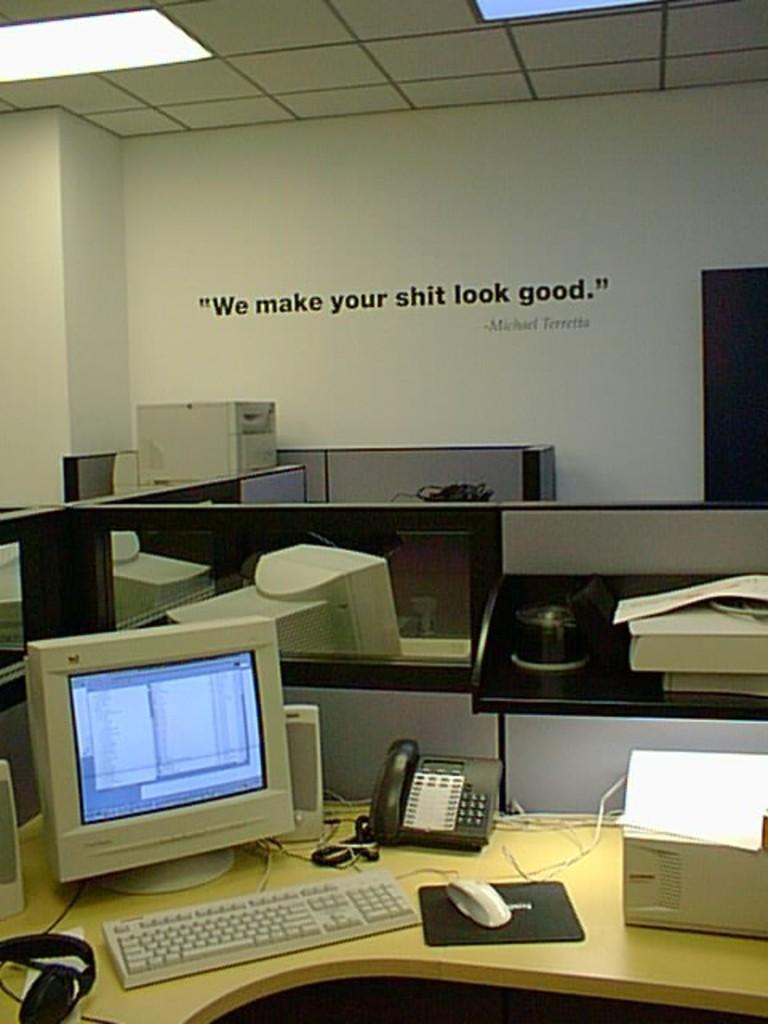What type of environment is depicted in the image? The image appears to depict an office setting. What can be seen on the desk in the image? Monitors, keyboards, mice, and phones are present on the desk. Are there any dividers in the room? Yes, there are partitions in the room. What phrase is written on the wall in the image? The phrase "We make your shit look good" is written on a wall. Can you see a wrench being used in the image? No, there is no wrench present in the image. Are there any cacti visible in the office setting? No, there are no cacti present in the image. 